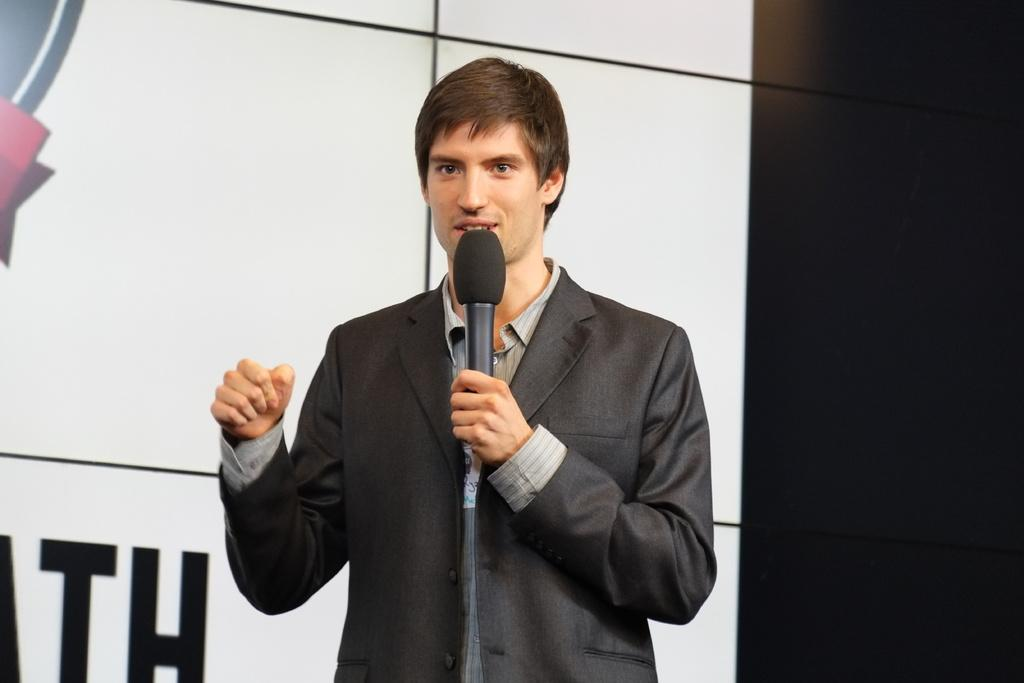What is happening in the image? There is a person in the image who is talking. What is the person holding in the image? The person is holding a microphone. What is the person wearing in the image? The person is wearing a suit. What type of rose is the person holding in the image? There is no rose present in the image; the person is holding a microphone. 